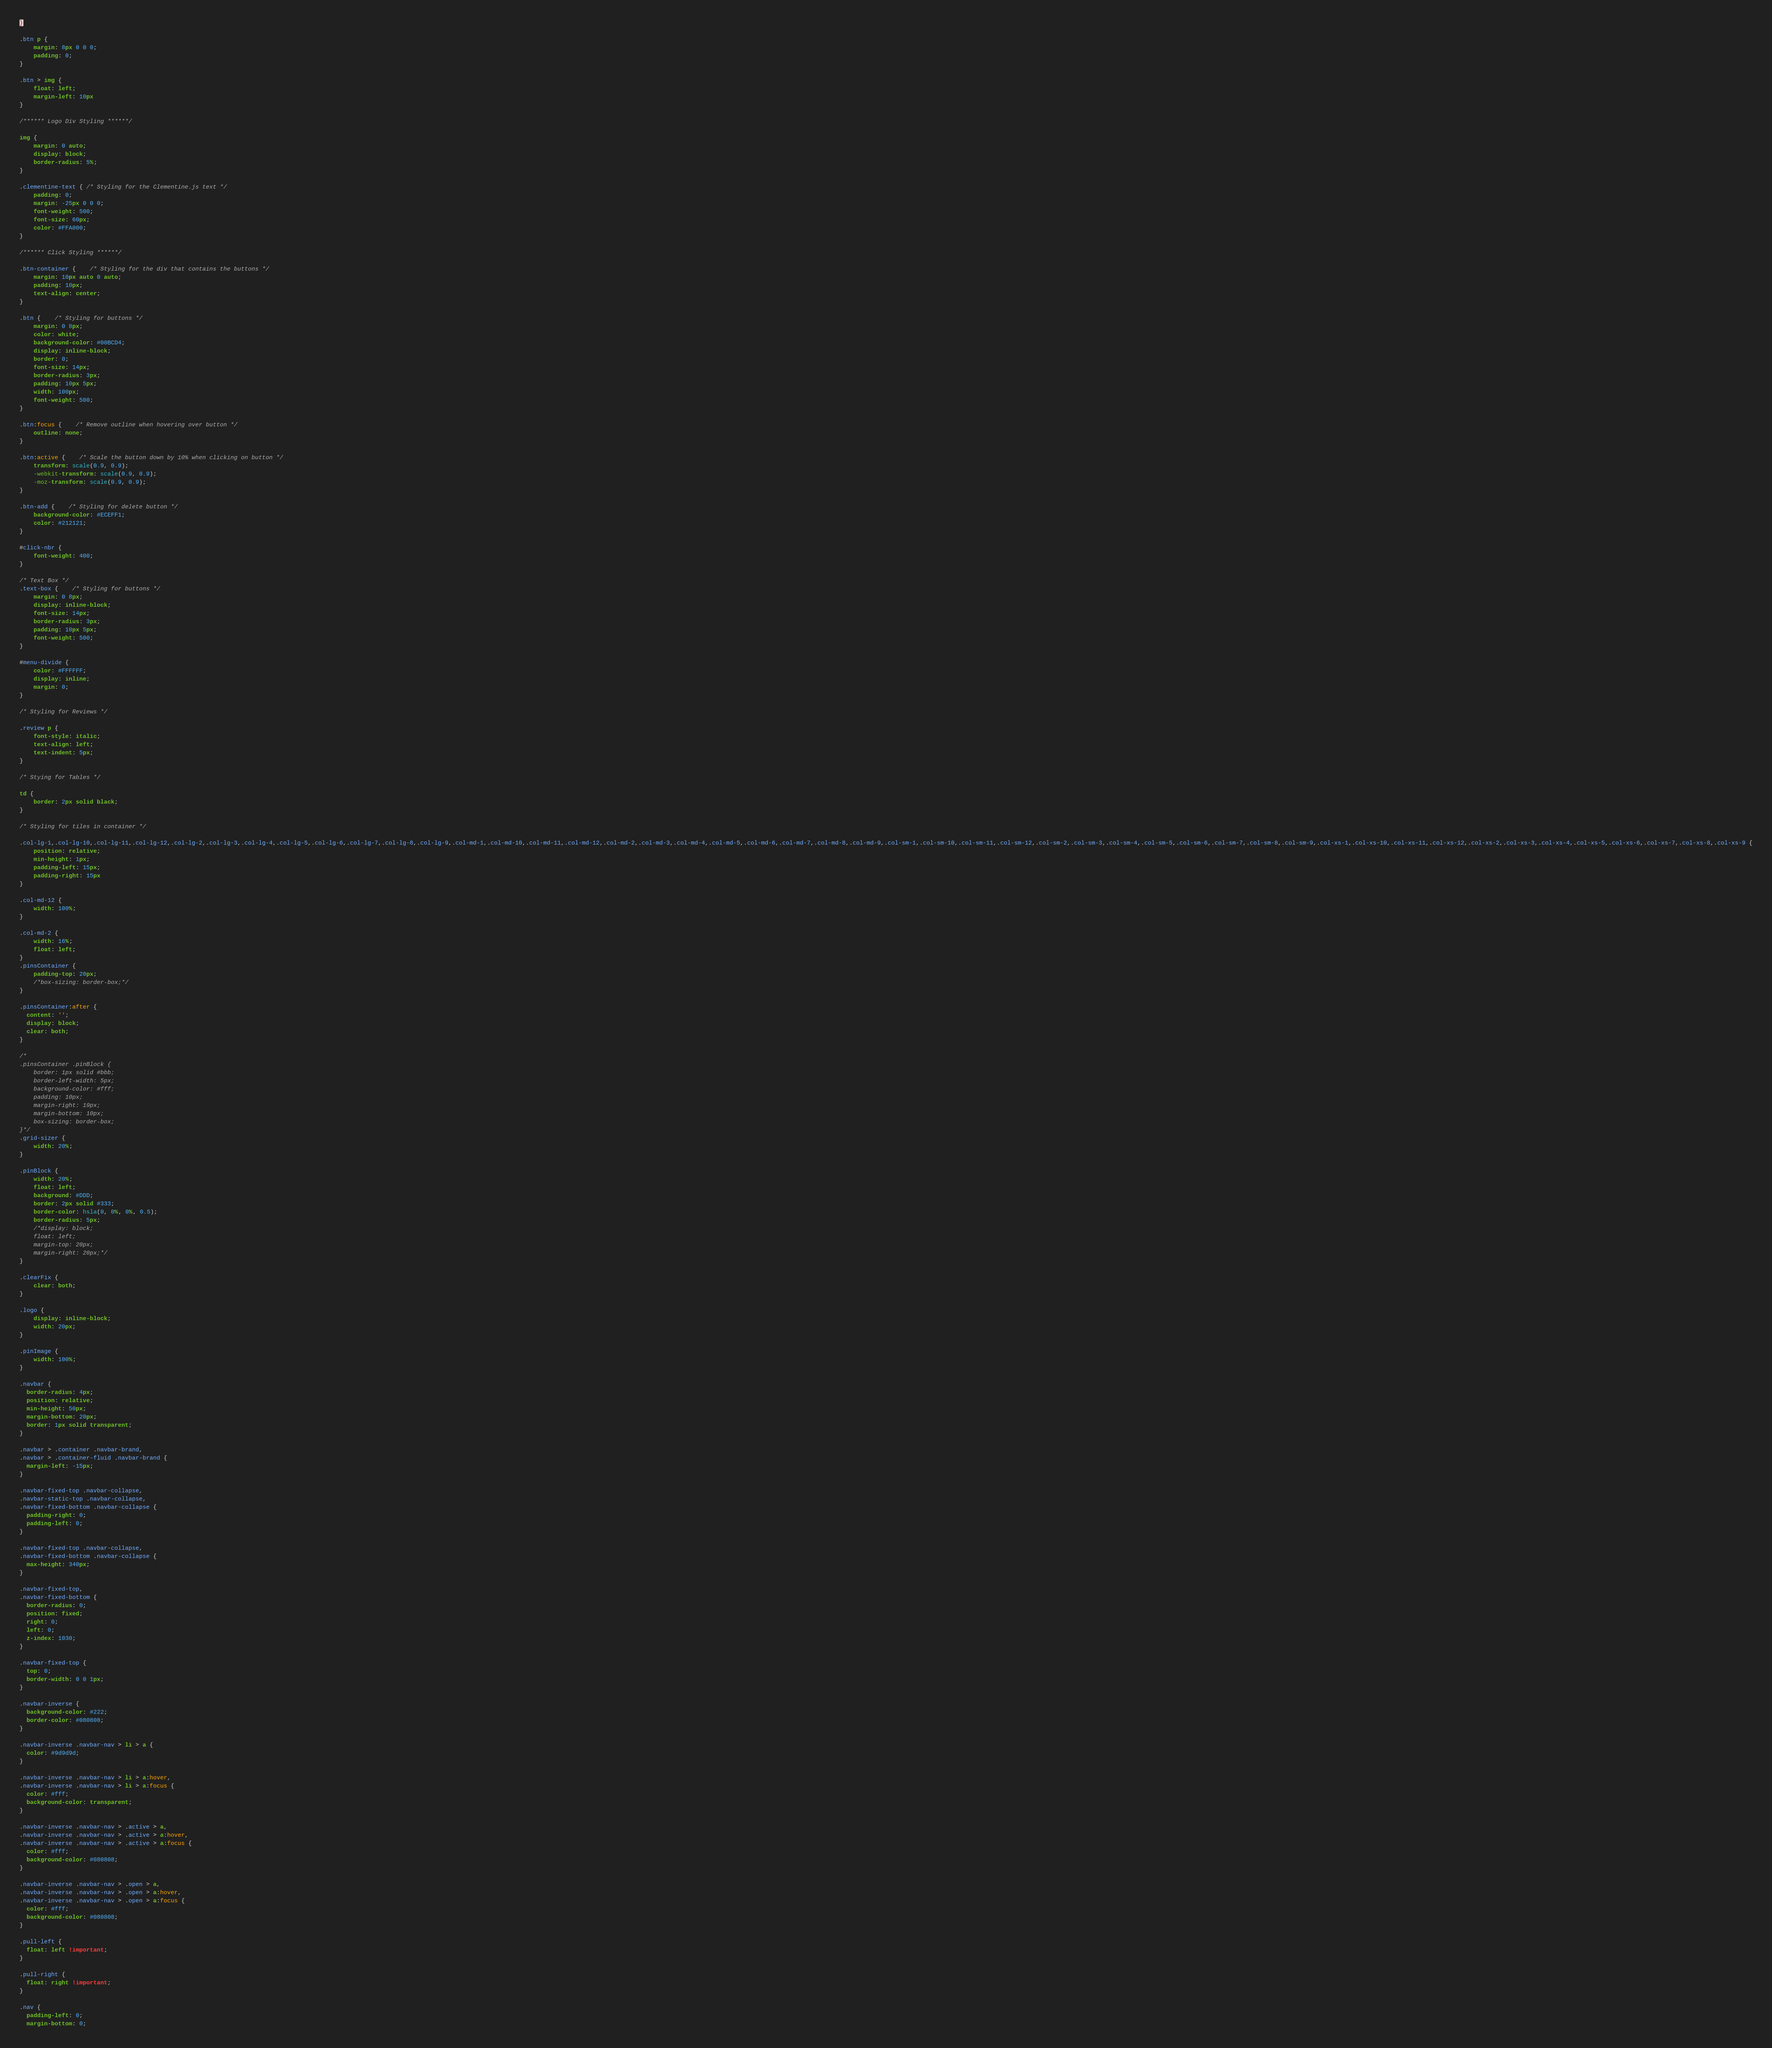Convert code to text. <code><loc_0><loc_0><loc_500><loc_500><_CSS_>}

.btn p {
	margin: 8px 0 0 0;
	padding: 0;
}

.btn > img {
	float: left;
	margin-left: 10px
}

/****** Logo Div Styling ******/

img {
	margin: 0 auto;
	display: block;
	border-radius: 5%;
}

.clementine-text { /* Styling for the Clementine.js text */
	padding: 0;
	margin: -25px 0 0 0;
	font-weight: 500;
	font-size: 60px;
	color: #FFA000;
}

/****** Click Styling ******/

.btn-container {	/* Styling for the div that contains the buttons */
	margin: 10px auto 0 auto;
	padding: 10px;
	text-align: center;
}

.btn {	/* Styling for buttons */
	margin: 0 8px;
	color: white;
	background-color: #00BCD4;
	display: inline-block;
	border: 0;
	font-size: 14px;
	border-radius: 3px;
	padding: 10px 5px;
	width: 100px;
	font-weight: 500;
}

.btn:focus {	/* Remove outline when hovering over button */
	outline: none;
}

.btn:active {	/* Scale the button down by 10% when clicking on button */
	transform: scale(0.9, 0.9);
	-webkit-transform: scale(0.9, 0.9);
	-moz-transform: scale(0.9, 0.9);
}

.btn-add {	/* Styling for delete button */
	background-color: #ECEFF1;
	color: #212121;
}

#click-nbr {
	font-weight: 400;
}

/* Text Box */
.text-box {	/* Styling for buttons */
	margin: 0 8px;
	display: inline-block;
	font-size: 14px;
	border-radius: 3px;
	padding: 10px 5px;
	font-weight: 500;
}

#menu-divide {
	color: #FFFFFF;
	display: inline;
	margin: 0;
}

/* Styling for Reviews */

.review p {
	font-style: italic;
	text-align: left;
	text-indent: 5px;
}

/* Stying for Tables */

td {
	border: 2px solid black;
}

/* Styling for tiles in container */

.col-lg-1,.col-lg-10,.col-lg-11,.col-lg-12,.col-lg-2,.col-lg-3,.col-lg-4,.col-lg-5,.col-lg-6,.col-lg-7,.col-lg-8,.col-lg-9,.col-md-1,.col-md-10,.col-md-11,.col-md-12,.col-md-2,.col-md-3,.col-md-4,.col-md-5,.col-md-6,.col-md-7,.col-md-8,.col-md-9,.col-sm-1,.col-sm-10,.col-sm-11,.col-sm-12,.col-sm-2,.col-sm-3,.col-sm-4,.col-sm-5,.col-sm-6,.col-sm-7,.col-sm-8,.col-sm-9,.col-xs-1,.col-xs-10,.col-xs-11,.col-xs-12,.col-xs-2,.col-xs-3,.col-xs-4,.col-xs-5,.col-xs-6,.col-xs-7,.col-xs-8,.col-xs-9 {
    position: relative;
    min-height: 1px;
    padding-left: 15px;
    padding-right: 15px
}

.col-md-12 {
	width: 100%;
}

.col-md-2 {
	width: 16%;
	float: left;
}
.pinsContainer {
    padding-top: 20px;
    /*box-sizing: border-box;*/
}

.pinsContainer:after {
  content: '';
  display: block;
  clear: both;
}

/*
.pinsContainer .pinBlock {
    border: 1px solid #bbb;
    border-left-width: 5px;
    background-color: #fff;
    padding: 10px;
    margin-right: 19px;
    margin-bottom: 10px;
    box-sizing: border-box;
}*/
.grid-sizer {
	width: 20%;
}

.pinBlock {
	width: 20%;
	float: left;
	background: #DDD;
	border: 2px solid #333;
	border-color: hsla(0, 0%, 0%, 0.5);
	border-radius: 5px;	
	/*display: block;
	float: left;
	margin-top: 20px;
	margin-right: 20px;*/
}

.clearFix {
	clear: both;
}

.logo {
	display: inline-block;
	width: 20px;
}

.pinImage {
	width: 100%;
}

.navbar {
  border-radius: 4px;
  position: relative;
  min-height: 50px;
  margin-bottom: 20px;
  border: 1px solid transparent;
}

.navbar > .container .navbar-brand,
.navbar > .container-fluid .navbar-brand {
  margin-left: -15px;
}

.navbar-fixed-top .navbar-collapse,
.navbar-static-top .navbar-collapse,
.navbar-fixed-bottom .navbar-collapse {
  padding-right: 0;
  padding-left: 0;
}
  
.navbar-fixed-top .navbar-collapse,
.navbar-fixed-bottom .navbar-collapse {
  max-height: 340px;
}  

.navbar-fixed-top,
.navbar-fixed-bottom {
  border-radius: 0;
  position: fixed;
  right: 0;
  left: 0;
  z-index: 1030;
}

.navbar-fixed-top {
  top: 0;
  border-width: 0 0 1px;
}

.navbar-inverse {
  background-color: #222;
  border-color: #080808;
}

.navbar-inverse .navbar-nav > li > a {
  color: #9d9d9d;
}

.navbar-inverse .navbar-nav > li > a:hover,
.navbar-inverse .navbar-nav > li > a:focus {
  color: #fff;
  background-color: transparent;
}

.navbar-inverse .navbar-nav > .active > a,
.navbar-inverse .navbar-nav > .active > a:hover,
.navbar-inverse .navbar-nav > .active > a:focus {
  color: #fff;
  background-color: #080808;
}

.navbar-inverse .navbar-nav > .open > a,
.navbar-inverse .navbar-nav > .open > a:hover,
.navbar-inverse .navbar-nav > .open > a:focus {
  color: #fff;
  background-color: #080808;
}

.pull-left {
  float: left !important;
}

.pull-right {
  float: right !important;
}

.nav {
  padding-left: 0;
  margin-bottom: 0;</code> 